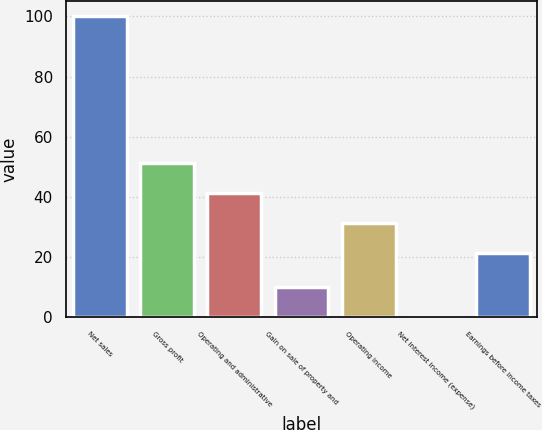Convert chart to OTSL. <chart><loc_0><loc_0><loc_500><loc_500><bar_chart><fcel>Net sales<fcel>Gross profit<fcel>Operating and administrative<fcel>Gain on sale of property and<fcel>Operating income<fcel>Net interest income (expense)<fcel>Earnings before income taxes<nl><fcel>100<fcel>51.27<fcel>41.28<fcel>10.09<fcel>31.29<fcel>0.1<fcel>21.3<nl></chart> 